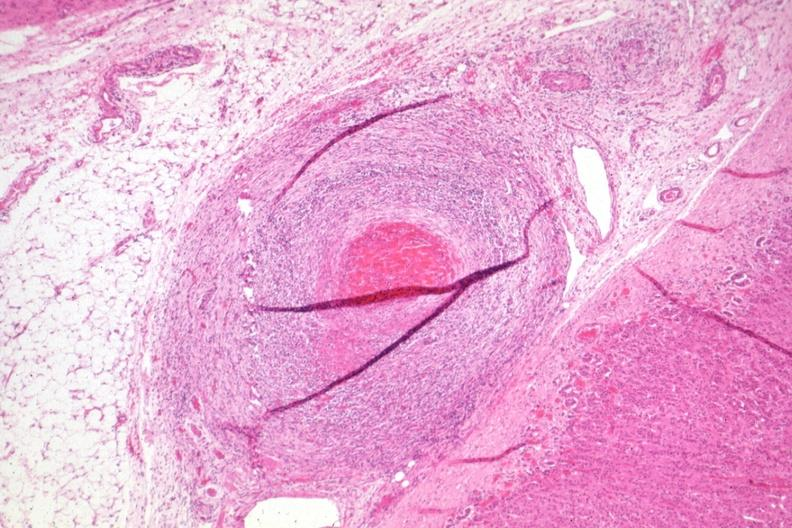s anencephaly present?
Answer the question using a single word or phrase. No 